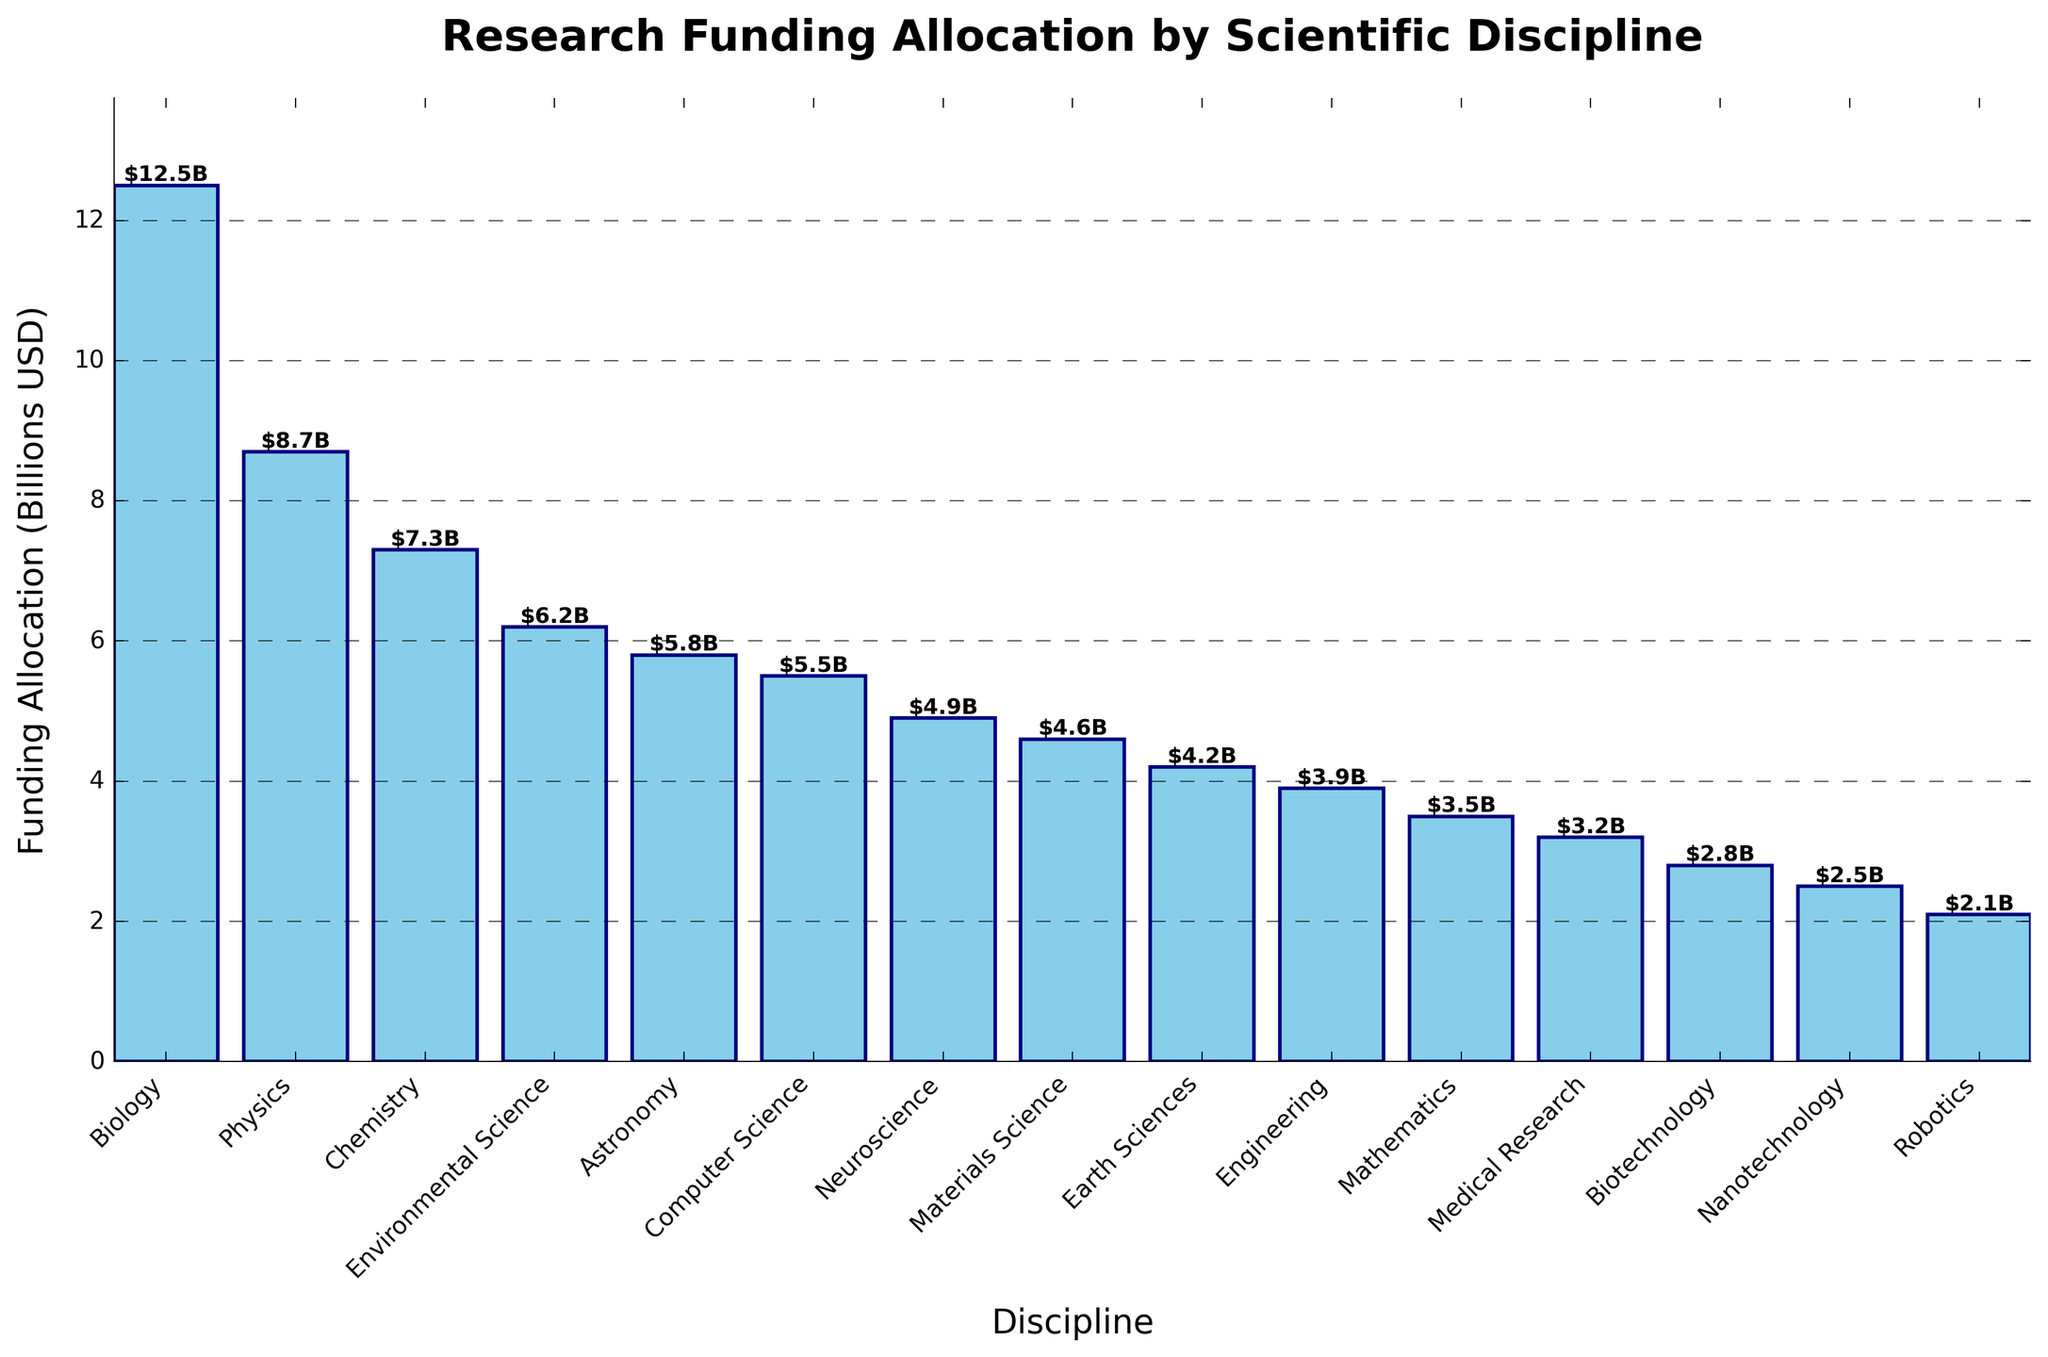What's the total funding allocation for all disciplines except Biotechnology and Robotics? Total funding for all disciplines is the sum of individual funding amounts: 12.5 + 8.7 + 7.3 + 6.2 + 5.8 + 5.5 + 4.9 + 4.6 + 4.2 + 3.9 + 3.5 + 3.2 + 2.8 + 2.5 + 2.1 =  80.7. Next, subtract the funding for Biotechnology and Robotics: 2.8 + 2.1 = 4.9. Finally, 80.7 - 4.9 = 75.8
Answer: 75.8 Which discipline receives the lowest funding allocation? From the chart, the funding allocation for Robotics is the lowest at 2.1 billion USD
Answer: Robotics What is the difference in funding between the highest and the lowest funded disciplines? The highest funding is for Biology at 12.5 billion USD, and the lowest is for Robotics at 2.1 billion USD. The difference is 12.5 - 2.1 = 10.4
Answer: 10.4 How much more funding does Biology receive compared to Neuroscience? The funding for Biology is 12.5 billion USD, and for Neuroscience, it's 4.9 billion USD. The difference is 12.5 - 4.9 = 7.6
Answer: 7.6 Which disciplines have a funding allocation greater than 5 billion USD? The disciplines with funding allocations greater than 5 billion USD are Biology (12.5), Physics (8.7), Chemistry (7.3), Environmental Science (6.2), and Astronomy (5.8)
Answer: Biology, Physics, Chemistry, Environmental Science, Astronomy What is the average funding allocation for all disciplines? To find the average, sum all the funding allocations and divide by the number of disciplines. The total funding allocation is 80.7 billion USD, and there are 15 disciplines. The average is 80.7 / 15 ≈ 5.38
Answer: 5.38 What is the median funding allocation for all disciplines? To find the median, first list all the funding allocations in ascending order: 2.1, 2.5, 2.8, 3.2, 3.5, 3.9, 4.2, 4.6, 4.9, 5.5, 5.8, 6.2, 7.3, 8.7, 12.5. The median value is the middle value, which is the 8th value in this list: 4.6
Answer: 4.6 Which discipline receives more funding: Computer Science or Earth Sciences? The funding for Computer Science is 5.5 billion USD, and for Earth Sciences, it's 4.2 billion USD. Computer Science receives more funding
Answer: Computer Science What percentage of the total funding is allocated to Physics and Chemistry combined? First find the combined allocation for Physics and Chemistry: 8.7 + 7.3 = 16. Then find the total funding allocation: 80.7. The percentage is (16 / 80.7) * 100 ≈ 19.83%
Answer: 19.83% 